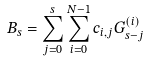Convert formula to latex. <formula><loc_0><loc_0><loc_500><loc_500>B _ { s } = \sum _ { j = 0 } ^ { s } \sum _ { i = 0 } ^ { N - 1 } c _ { i , j } G _ { s - j } ^ { ( i ) }</formula> 